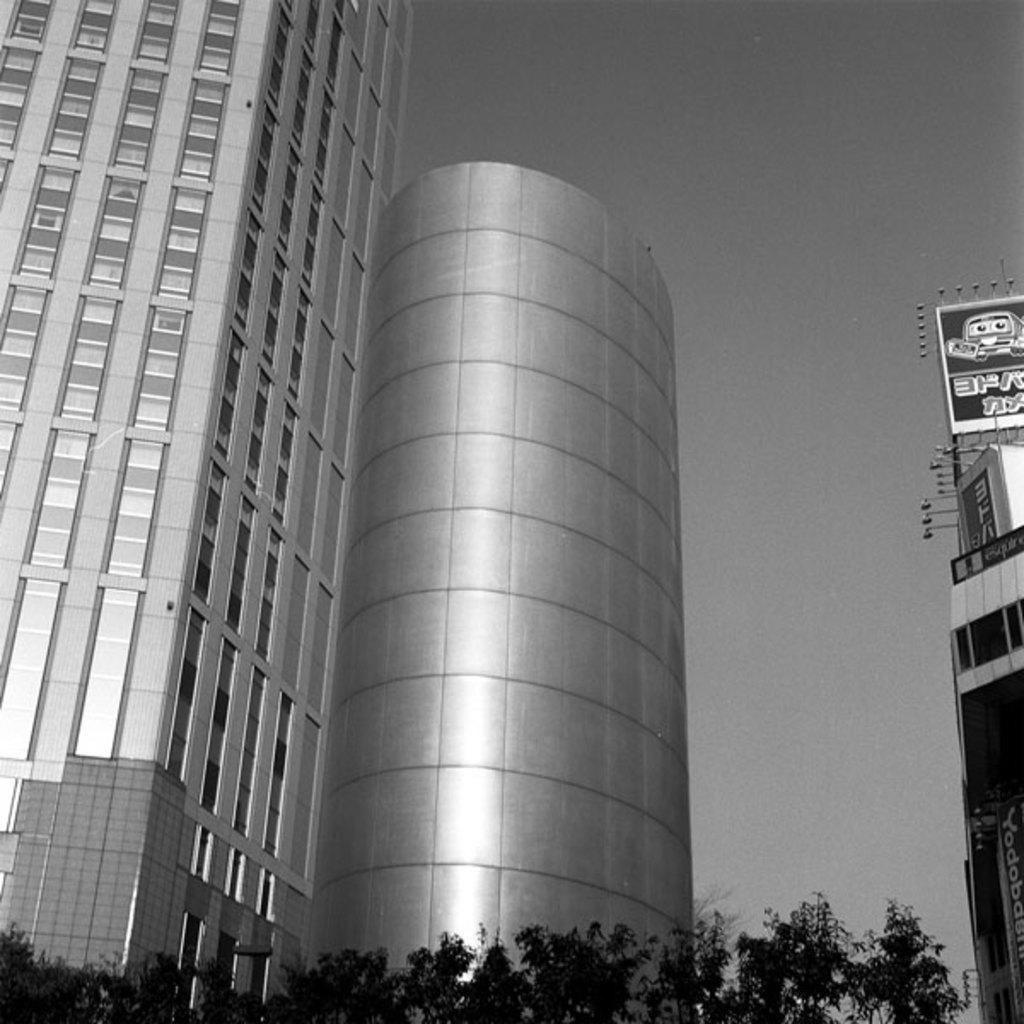Can you describe this image briefly? In this image, we can see buildings, hoardings and trees. 